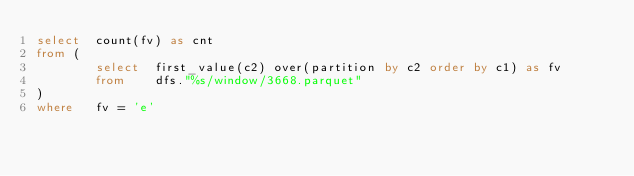<code> <loc_0><loc_0><loc_500><loc_500><_SQL_>select  count(fv) as cnt
from (
        select  first_value(c2) over(partition by c2 order by c1) as fv
        from    dfs."%s/window/3668.parquet"
)
where   fv = 'e'
</code> 